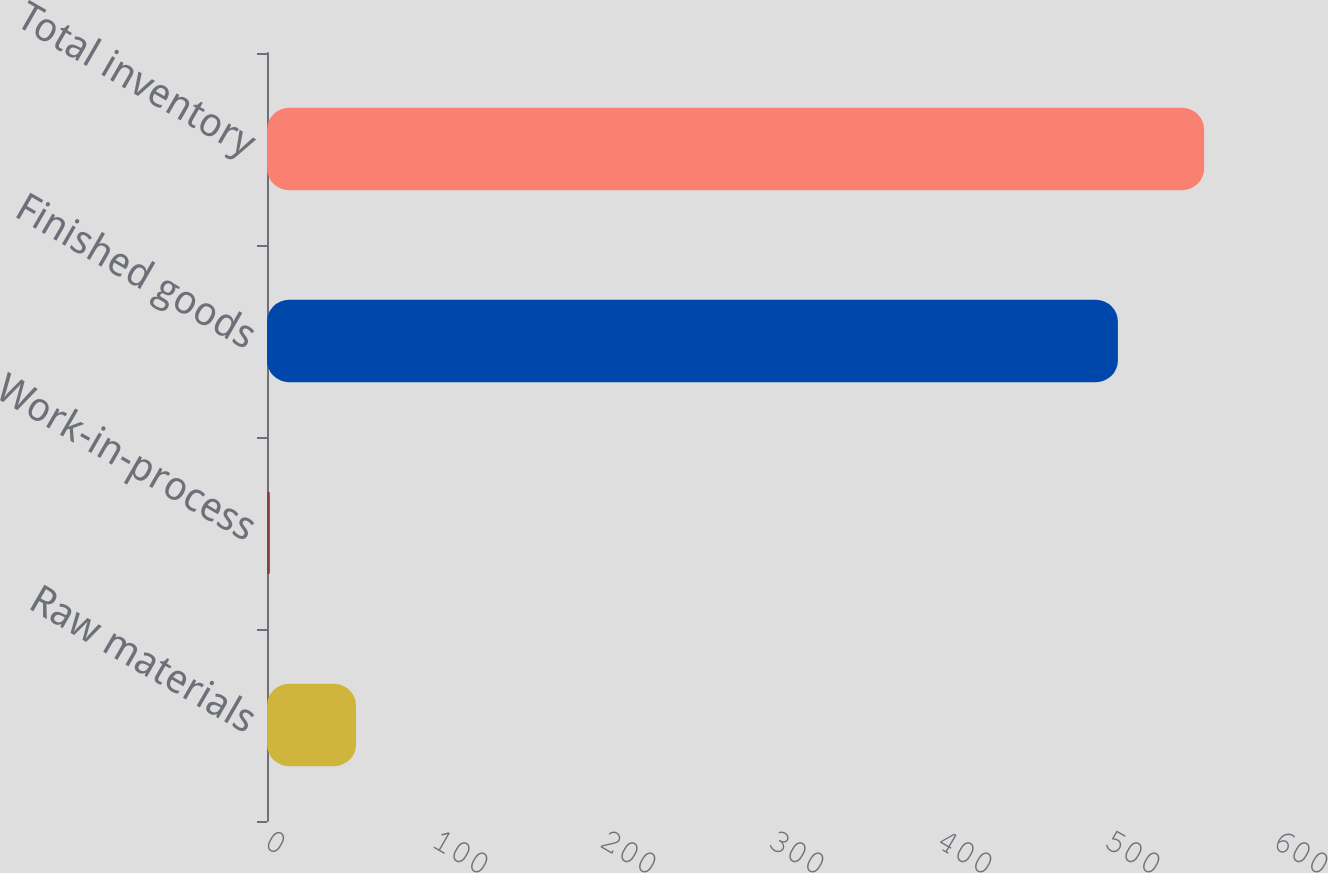Convert chart. <chart><loc_0><loc_0><loc_500><loc_500><bar_chart><fcel>Raw materials<fcel>Work-in-process<fcel>Finished goods<fcel>Total inventory<nl><fcel>53.02<fcel>1.7<fcel>506.5<fcel>557.82<nl></chart> 